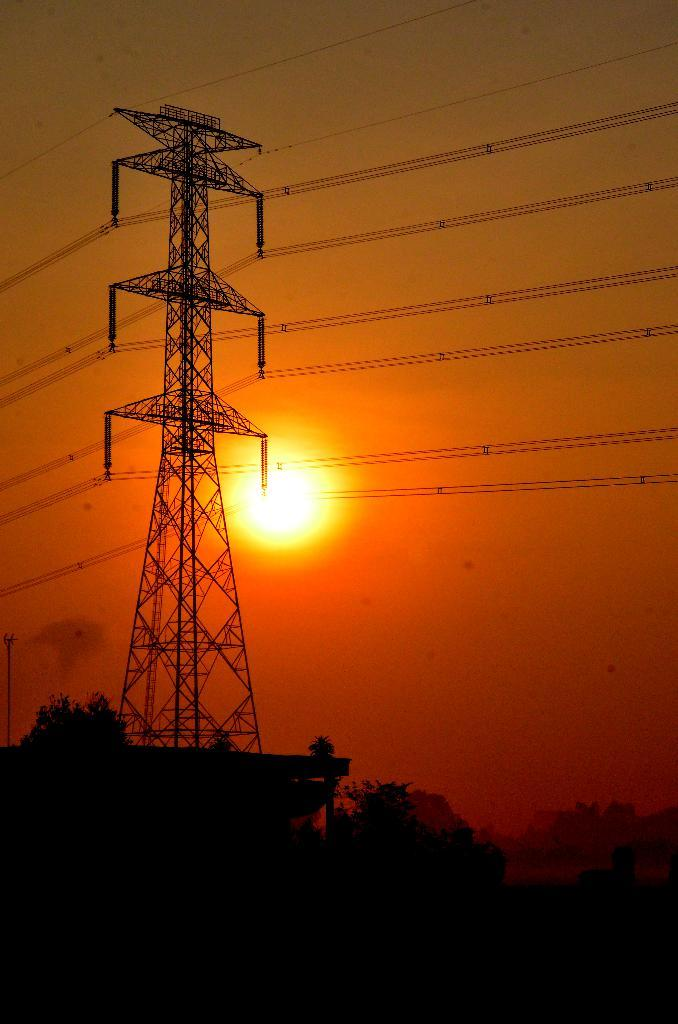What type of natural elements can be seen in the image? There are trees in the image. What man-made structure is present in the image? There is an electric tower in the image. What connects the electric tower to other structures? There are wires in the image. What can be seen in the background of the image? The sun and the sky are visible in the background of the image. What type of calculator is being used to measure the height of the trees in the image? There is no calculator present in the image, and the height of the trees is not being measured. What type of rake is being used to clear the wires in the image? There is no rake present in the image, and the wires are not being cleared. 